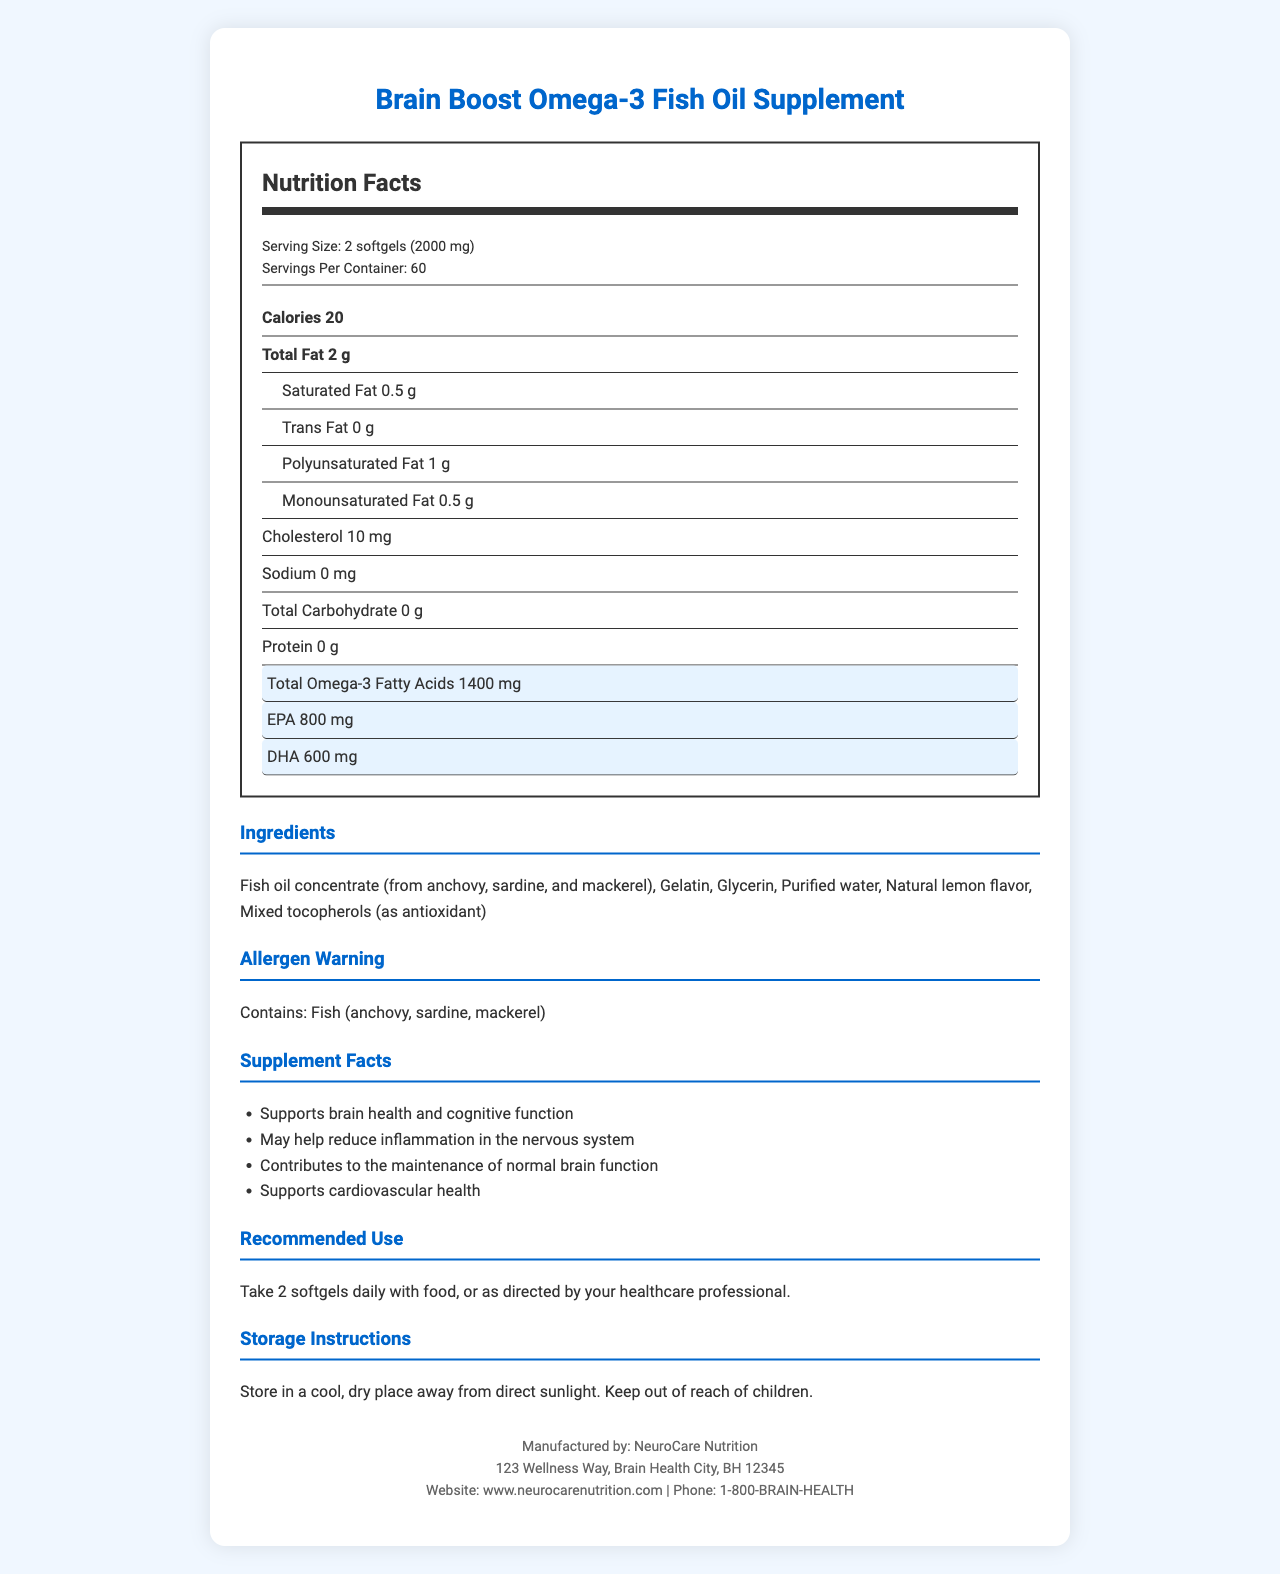what is the serving size of the Brain Boost Omega-3 Fish Oil Supplement? The serving size is indicated as "2 softgels (2000 mg)" in the serving information of the nutrition label.
Answer: 2 softgels (2000 mg) how many servings are in one container? The nutrition label mentions "Servings Per Container: 60".
Answer: 60 how many calories are there per serving? The calorie content per serving is explicitly listed as "Calories 20".
Answer: 20 what type of fats are present in the supplement? The nutrition label lists total fat and further breaks it down into saturated fat, trans fat, polyunsaturated fat, and monounsaturated fat.
Answer: Total Fat, Saturated Fat, Trans Fat, Polyunsaturated Fat, Monounsaturated Fat does the supplement contain any protein or carbohydrates? Both protein and total carbohydrate are listed as "0 g" per serving in the nutrition label.
Answer: No what is the amount of DHA per serving? DHA content is specifically highlighted and listed as "DHA 600 mg" on the nutrition label.
Answer: 600 mg does the product contain any allergens? The allergen warning states "Contains: Fish (anchovy, sardine, mackerel)".
Answer: Yes how should the supplement be stored? The storage instructions clearly specify to store in a cool, dry place away from direct sunlight and to keep it out of reach of children.
Answer: Store in a cool, dry place away from direct sunlight. Keep out of reach of children. who manufactures the Brain Boost Omega-3 Fish Oil Supplement? The manufacturer info section lists the name "NeuroCare Nutrition" as the manufacturer.
Answer: NeuroCare Nutrition what are the benefits of this supplement? A. Supports brain health B. Reduces inflammation C. Contributes to normal brain function D. All of the above The Supplement Facts section states the benefits, including brain health support, reducing inflammation, and contributing to normal brain function.
Answer: D how much EPA is in each serving? A. 400 mg B. 600 mg C. 800 mg D. 1000 mg EPA content is highlighted as "EPA 800 mg" per serving.
Answer: C is the product gluten-free? (Yes/No) The document mentions that the product is "gluten-free".
Answer: Yes summarize the main idea of the document. The document provides comprehensive information regarding the nutritional content and health benefits of the omega-3 supplement, along with practical usage and storage guidelines, and background on the product's quality assurance.
Answer: The document is a detailed Nutrition Facts Label for the "Brain Boost Omega-3 Fish Oil Supplement". It includes serving size, nutrient breakdown, ingredient list, allergen warning, supplement benefits, recommended use, storage instructions, and manufacturer information. The label highlights the omega-3 content specifically DHA and EPA, indicating the supplement supports brain health, cognitive function, and cardiovascular health. The product is also noted to be tested for purity, sustainably sourced, non-GMO, and gluten-free. what will be the expiration date of this supplement? The document does not provide any details about the expiration date of the supplement.
Answer: Not enough information 